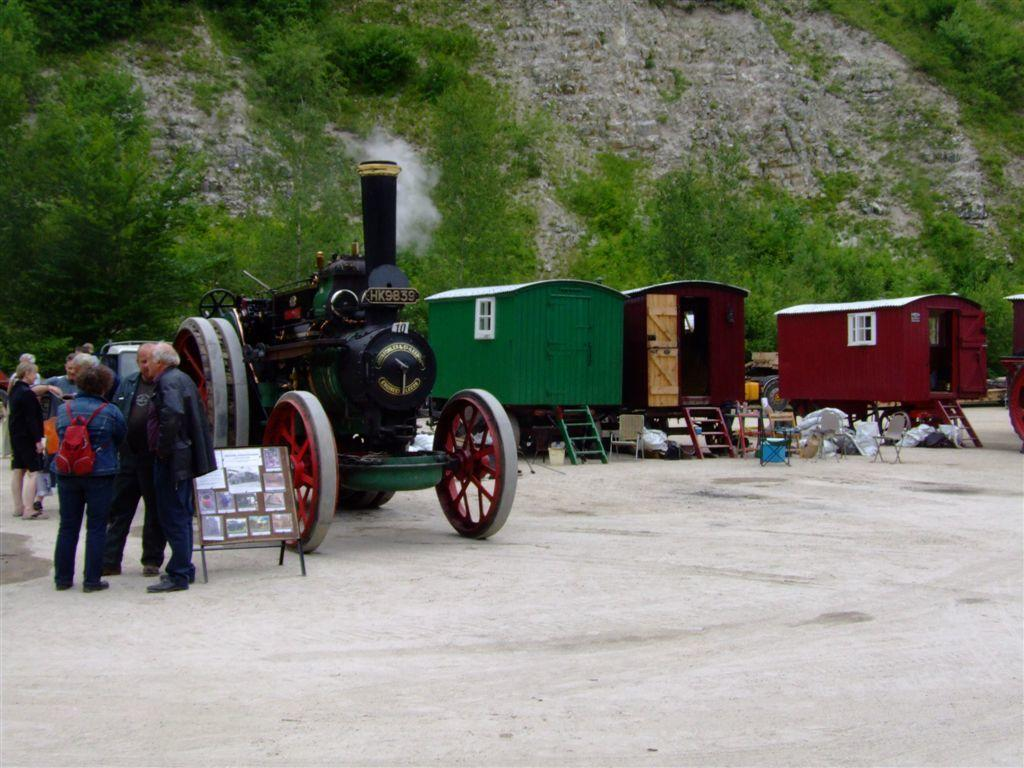What is the main subject in the image? There is a vehicle in the image. What structures can be seen in the image? There are sheds in the image. What is the board used for in the image? The board's purpose is not clear from the image, but it is present. What else can be seen in the image besides the vehicle and sheds? There are objects, a group of people standing on the ground, plants, trees, and a rock visible in the image. What type of bear can be seen interacting with the group of people in the image? There is no bear present in the image; it features a vehicle, sheds, a board, objects, people, plants, trees, and a rock. 